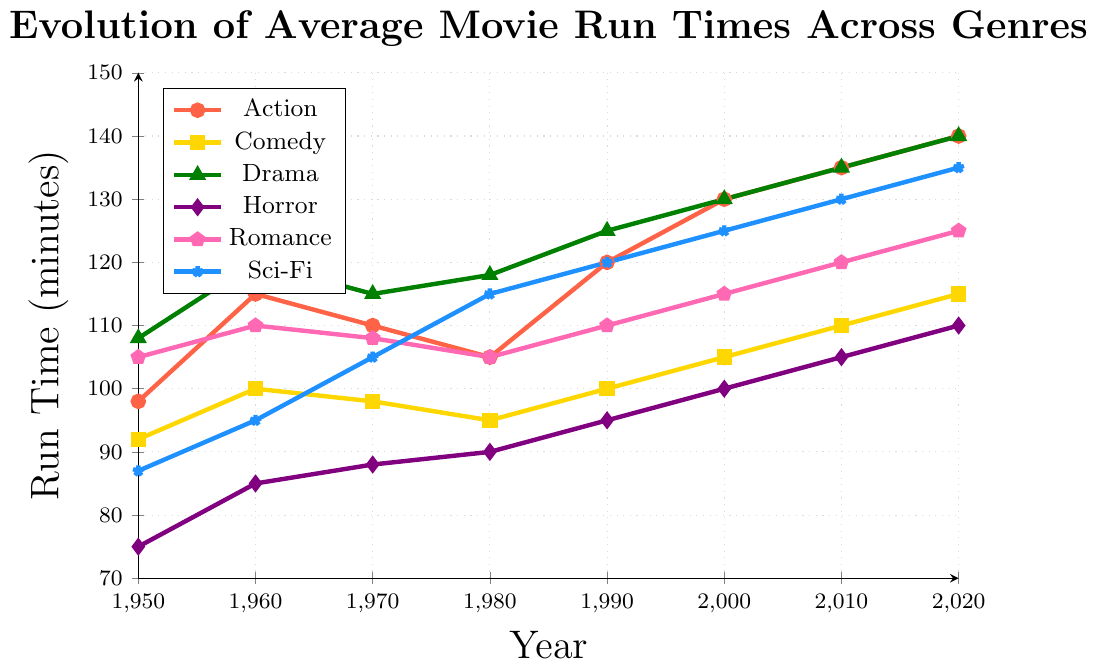Which genre has seen the greatest increase in average run time from 1950 to 2020? The average run time of Action movies in 1950 was 98 minutes and increased to 140 minutes in 2020, a difference of 42 minutes. Comparatively, Comedy increased by 23 minutes, Drama by 32 minutes, Horror by 35 minutes, Romance by 20 minutes, and Sci-Fi by 48 minutes. Sci-Fi has seen the greatest increase.
Answer: Sci-Fi By how many minutes did the average run time of Horror movies increase from 1950 to 1980? The average run time of Horror movies in 1950 was 75 minutes and in 1980 it was 90 minutes. The increase is 90 - 75 = 15 minutes.
Answer: 15 minutes What was the average run time of Drama movies in 1980? Looking at the figure, for the year 1980, the average run time for Drama movies is listed.
Answer: 118 minutes Which genre had a run time of 125 minutes in the year 2000? In the year 2000, the run times are 130 for Action, 105 for Comedy, 130 for Drama, 100 for Horror, 115 for Romance, and 125 for Sci-Fi.
Answer: Sci-Fi How did the average run time of Romance movies change between 1950 and 2020? In 1950, the run time of Romance movies was 105 minutes and in 2020 it was 125 minutes. The change is 125 - 105 = 20 minutes.
Answer: Increased by 20 minutes Which genre had the shortest run time in 1950 and what was it? In 1950, the genres have the following run times: Action (98), Comedy (92), Drama (108), Horror (75), Romance (105), and Sci-Fi (87). The shortest run time is 75 minutes for Horror.
Answer: Horror, 75 minutes What is the difference in the run times between Drama and Comedy movies in 2020? The average run time for Drama in 2020 is 140 minutes, and for Comedy, it is 115 minutes. The difference is 140 - 115 = 25 minutes.
Answer: 25 minutes During which decade did Action movies see the most significant increase in average run time? Examining the intervals for Action movie run times: 1950-1960 (17 min), 1960-1970 (-5 min), 1970-1980 (-5 min), 1980-1990 (15 min), 1990-2000 (10 min), 2000-2010 (5 min), 2010-2020 (5 min). The most significant increase was 1950-1960.
Answer: 1950-1960 What can be said about the trends in average run times of Comedy and Romance movies from 1950 to 2020? Comedy movies show a gradual increase from 92 to 115 minutes, while Romance movies have a more varied increase from 105 to 125 minutes. Both genres show an increasing trend, but Comedy is more gradual.
Answer: Both increased, Comedy gradually, Romance varied 